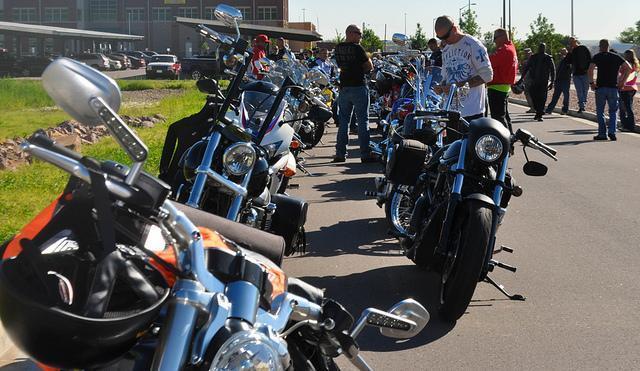How many motorcycles can be seen?
Give a very brief answer. 4. How many people are visible?
Give a very brief answer. 4. 